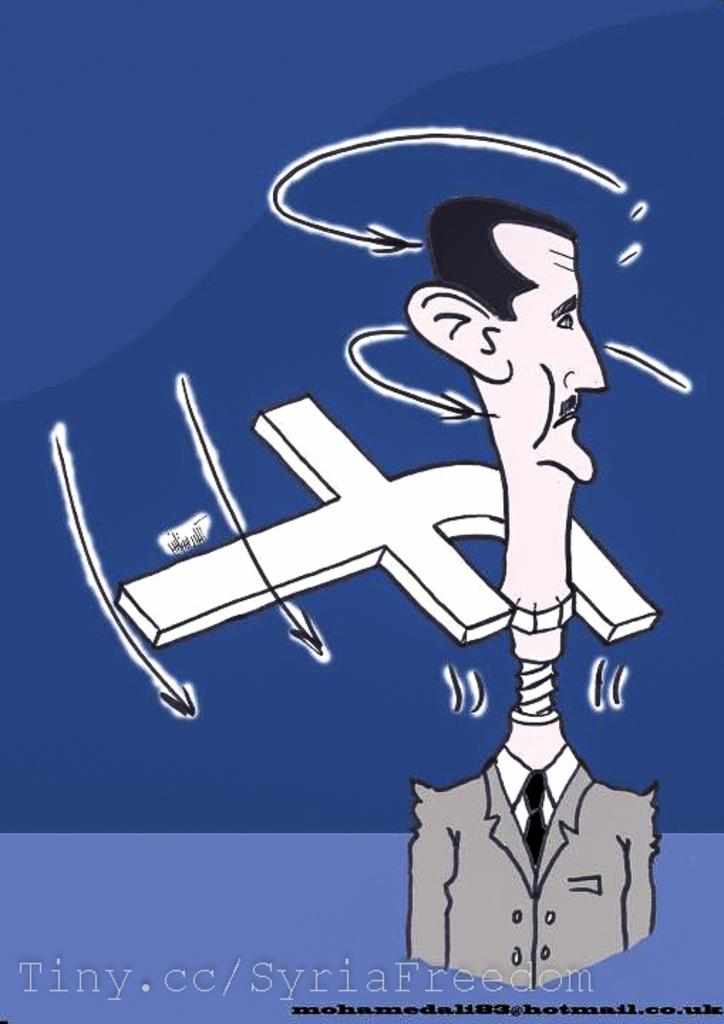<image>
Summarize the visual content of the image. Drawing showing a man with a long neck and the letter F around him. 